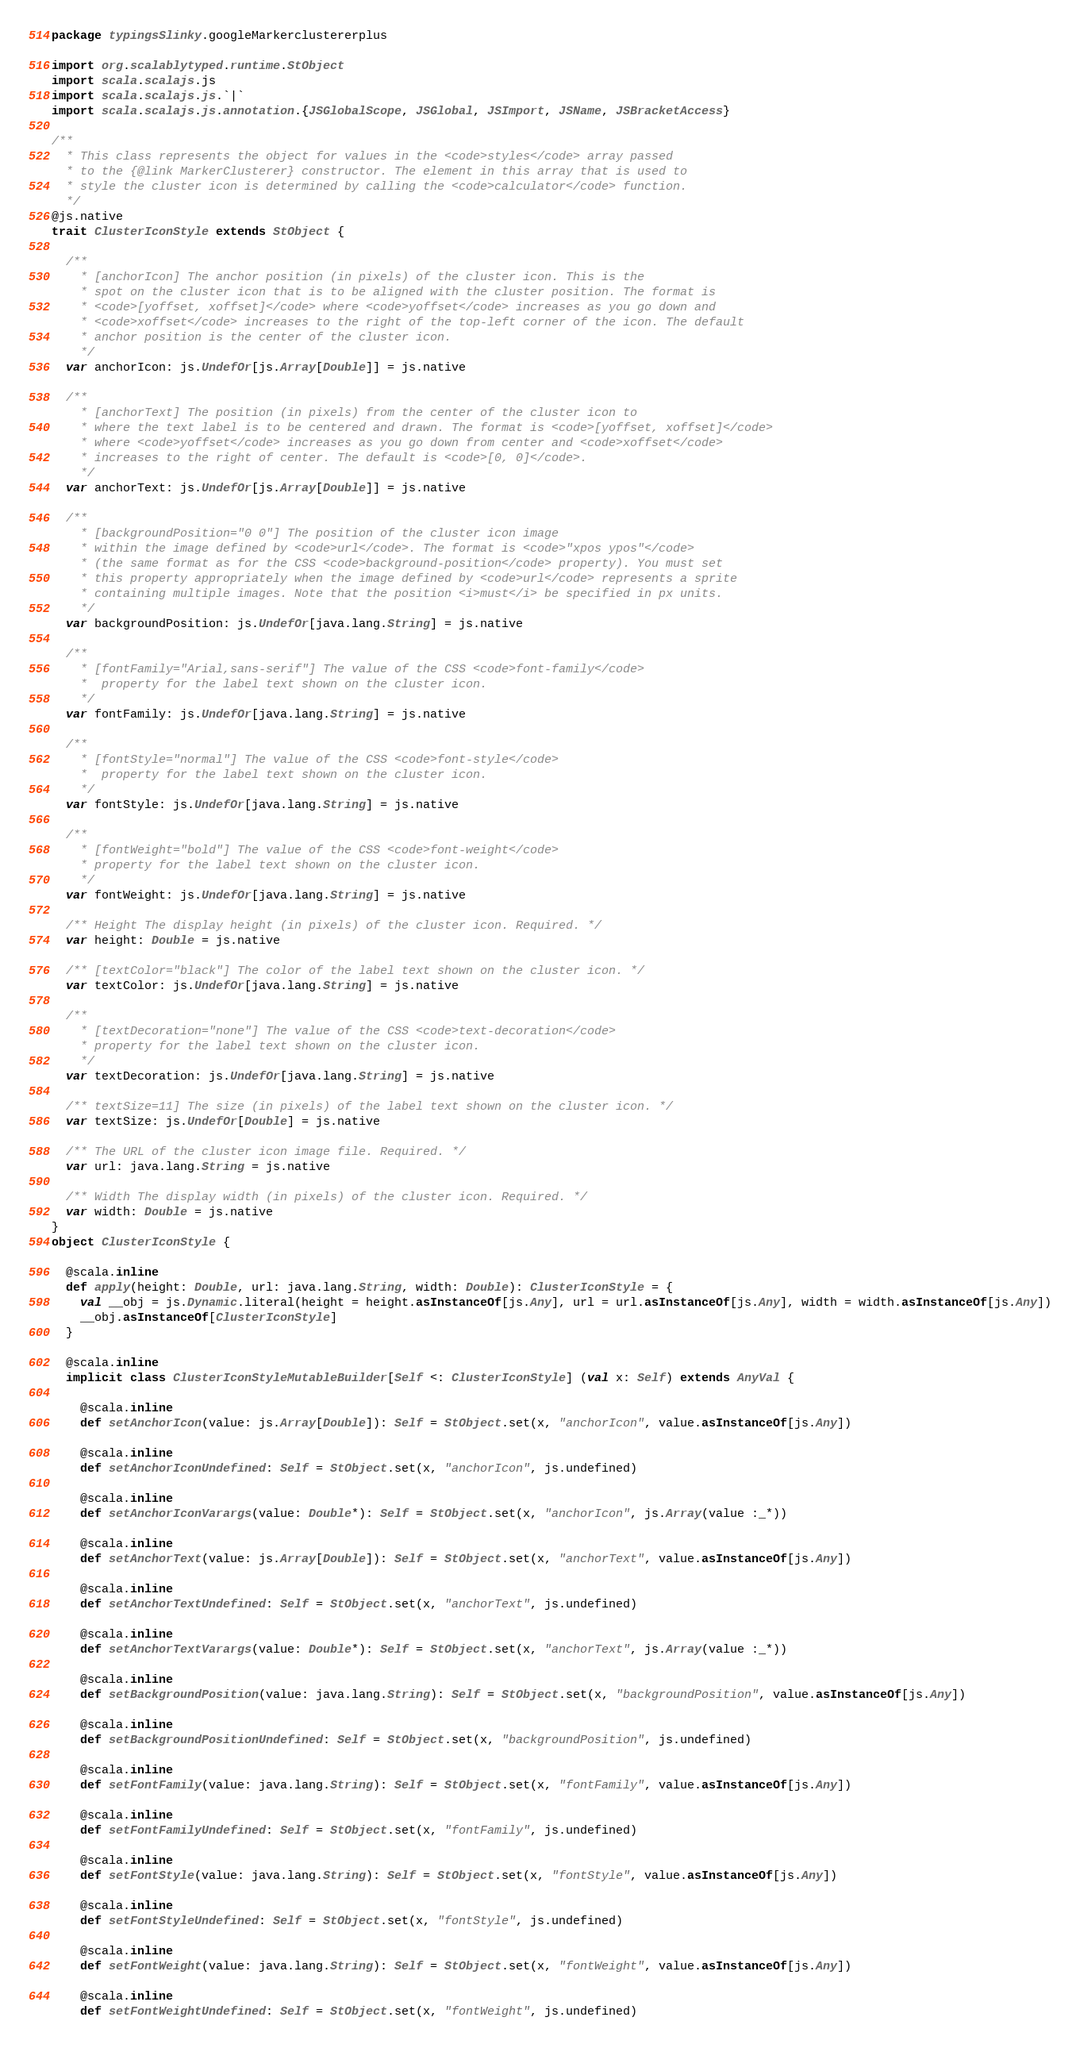<code> <loc_0><loc_0><loc_500><loc_500><_Scala_>package typingsSlinky.googleMarkerclustererplus

import org.scalablytyped.runtime.StObject
import scala.scalajs.js
import scala.scalajs.js.`|`
import scala.scalajs.js.annotation.{JSGlobalScope, JSGlobal, JSImport, JSName, JSBracketAccess}

/**
  * This class represents the object for values in the <code>styles</code> array passed
  * to the {@link MarkerClusterer} constructor. The element in this array that is used to
  * style the cluster icon is determined by calling the <code>calculator</code> function.
  */
@js.native
trait ClusterIconStyle extends StObject {
  
  /**
    * [anchorIcon] The anchor position (in pixels) of the cluster icon. This is the
    * spot on the cluster icon that is to be aligned with the cluster position. The format is
    * <code>[yoffset, xoffset]</code> where <code>yoffset</code> increases as you go down and
    * <code>xoffset</code> increases to the right of the top-left corner of the icon. The default
    * anchor position is the center of the cluster icon.
    */
  var anchorIcon: js.UndefOr[js.Array[Double]] = js.native
  
  /**
    * [anchorText] The position (in pixels) from the center of the cluster icon to
    * where the text label is to be centered and drawn. The format is <code>[yoffset, xoffset]</code>
    * where <code>yoffset</code> increases as you go down from center and <code>xoffset</code>
    * increases to the right of center. The default is <code>[0, 0]</code>.
    */
  var anchorText: js.UndefOr[js.Array[Double]] = js.native
  
  /**
    * [backgroundPosition="0 0"] The position of the cluster icon image
    * within the image defined by <code>url</code>. The format is <code>"xpos ypos"</code>
    * (the same format as for the CSS <code>background-position</code> property). You must set
    * this property appropriately when the image defined by <code>url</code> represents a sprite
    * containing multiple images. Note that the position <i>must</i> be specified in px units.
    */
  var backgroundPosition: js.UndefOr[java.lang.String] = js.native
  
  /**
    * [fontFamily="Arial,sans-serif"] The value of the CSS <code>font-family</code>
    *  property for the label text shown on the cluster icon.
    */
  var fontFamily: js.UndefOr[java.lang.String] = js.native
  
  /**
    * [fontStyle="normal"] The value of the CSS <code>font-style</code>
    *  property for the label text shown on the cluster icon.
    */
  var fontStyle: js.UndefOr[java.lang.String] = js.native
  
  /**
    * [fontWeight="bold"] The value of the CSS <code>font-weight</code>
    * property for the label text shown on the cluster icon.
    */
  var fontWeight: js.UndefOr[java.lang.String] = js.native
  
  /** Height The display height (in pixels) of the cluster icon. Required. */
  var height: Double = js.native
  
  /** [textColor="black"] The color of the label text shown on the cluster icon. */
  var textColor: js.UndefOr[java.lang.String] = js.native
  
  /**
    * [textDecoration="none"] The value of the CSS <code>text-decoration</code>
    * property for the label text shown on the cluster icon.
    */
  var textDecoration: js.UndefOr[java.lang.String] = js.native
  
  /** textSize=11] The size (in pixels) of the label text shown on the cluster icon. */
  var textSize: js.UndefOr[Double] = js.native
  
  /** The URL of the cluster icon image file. Required. */
  var url: java.lang.String = js.native
  
  /** Width The display width (in pixels) of the cluster icon. Required. */
  var width: Double = js.native
}
object ClusterIconStyle {
  
  @scala.inline
  def apply(height: Double, url: java.lang.String, width: Double): ClusterIconStyle = {
    val __obj = js.Dynamic.literal(height = height.asInstanceOf[js.Any], url = url.asInstanceOf[js.Any], width = width.asInstanceOf[js.Any])
    __obj.asInstanceOf[ClusterIconStyle]
  }
  
  @scala.inline
  implicit class ClusterIconStyleMutableBuilder[Self <: ClusterIconStyle] (val x: Self) extends AnyVal {
    
    @scala.inline
    def setAnchorIcon(value: js.Array[Double]): Self = StObject.set(x, "anchorIcon", value.asInstanceOf[js.Any])
    
    @scala.inline
    def setAnchorIconUndefined: Self = StObject.set(x, "anchorIcon", js.undefined)
    
    @scala.inline
    def setAnchorIconVarargs(value: Double*): Self = StObject.set(x, "anchorIcon", js.Array(value :_*))
    
    @scala.inline
    def setAnchorText(value: js.Array[Double]): Self = StObject.set(x, "anchorText", value.asInstanceOf[js.Any])
    
    @scala.inline
    def setAnchorTextUndefined: Self = StObject.set(x, "anchorText", js.undefined)
    
    @scala.inline
    def setAnchorTextVarargs(value: Double*): Self = StObject.set(x, "anchorText", js.Array(value :_*))
    
    @scala.inline
    def setBackgroundPosition(value: java.lang.String): Self = StObject.set(x, "backgroundPosition", value.asInstanceOf[js.Any])
    
    @scala.inline
    def setBackgroundPositionUndefined: Self = StObject.set(x, "backgroundPosition", js.undefined)
    
    @scala.inline
    def setFontFamily(value: java.lang.String): Self = StObject.set(x, "fontFamily", value.asInstanceOf[js.Any])
    
    @scala.inline
    def setFontFamilyUndefined: Self = StObject.set(x, "fontFamily", js.undefined)
    
    @scala.inline
    def setFontStyle(value: java.lang.String): Self = StObject.set(x, "fontStyle", value.asInstanceOf[js.Any])
    
    @scala.inline
    def setFontStyleUndefined: Self = StObject.set(x, "fontStyle", js.undefined)
    
    @scala.inline
    def setFontWeight(value: java.lang.String): Self = StObject.set(x, "fontWeight", value.asInstanceOf[js.Any])
    
    @scala.inline
    def setFontWeightUndefined: Self = StObject.set(x, "fontWeight", js.undefined)</code> 